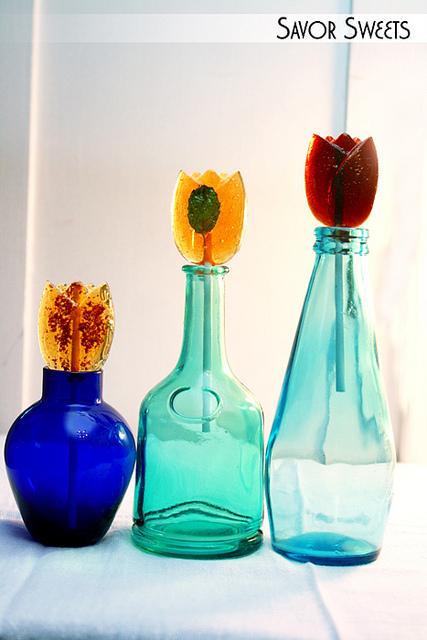Are these flowers real?
Write a very short answer. No. How many vases are there?
Answer briefly. 3. What are featured?
Answer briefly. Vases. 